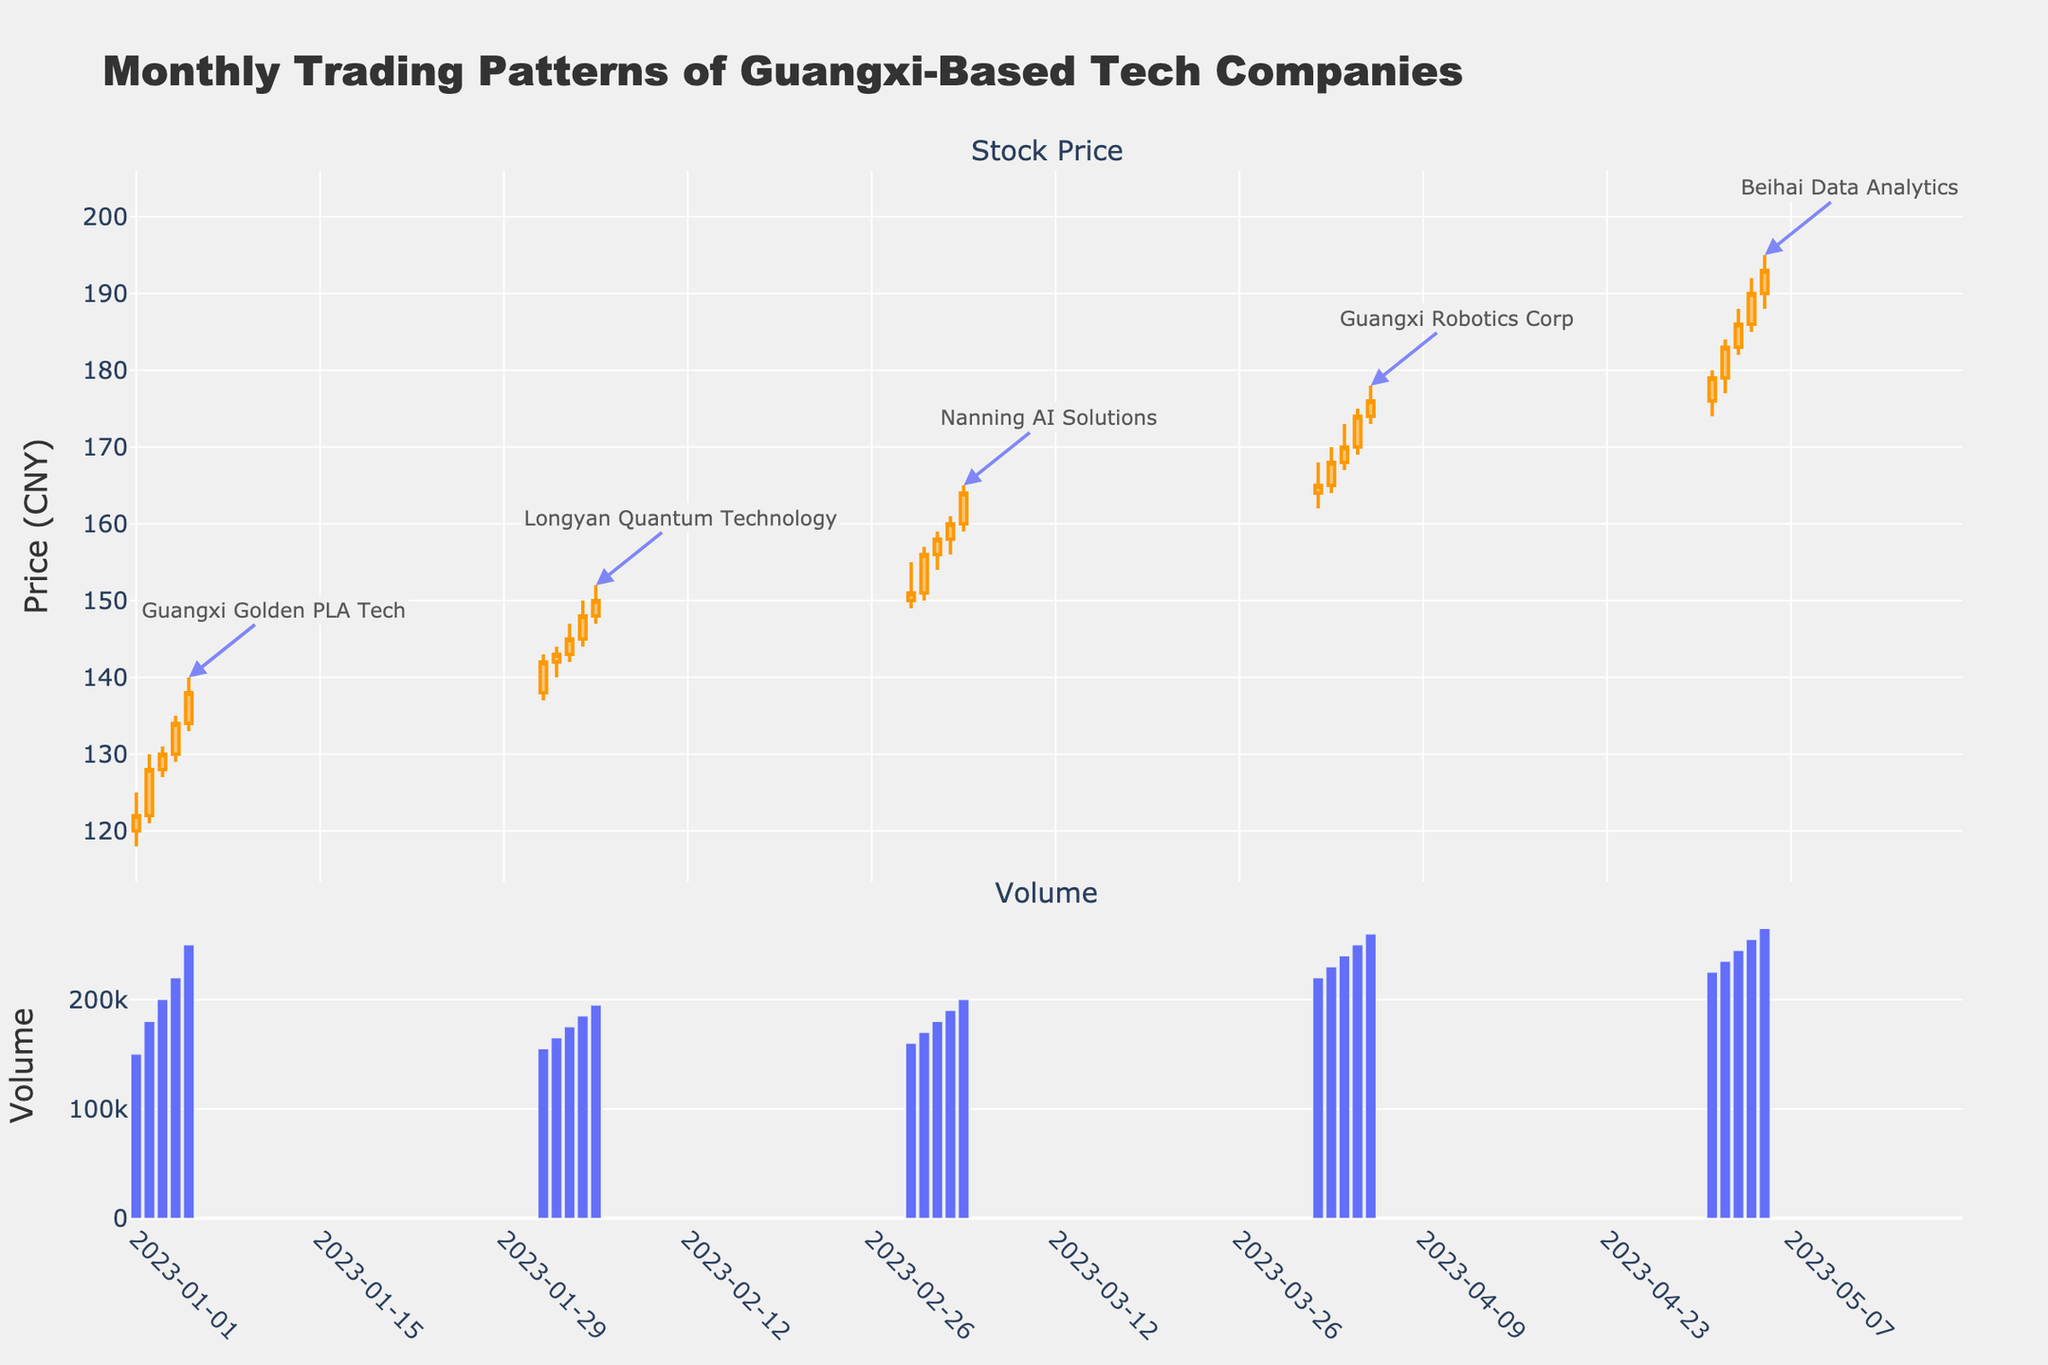What is the title of the plot? The title is positioned at the top of the figure and it provides an overview of the content being displayed.
Answer: Monthly Trading Patterns of Guangxi-Based Tech Companies What is the color used for increasing candlestick lines? The increasing candlestick lines are shown in orange color.
Answer: Orange Which company has the highest trading volume on the chart? Looking at the bar chart for volume, the highest trading volume can be found for Beihai Data Analytics on May 5th.
Answer: Beihai Data Analytics Compare the closing stock prices of Guangxi Golden PLA Tech and Longyan Quantum Technology. Which one ended higher in their respective trading months? Guangxi Golden PLA Tech’s closing price on January 5th was 138, while Longyan Quantum Technology’s closing price on February 5th was 150. Since 150 > 138, Longyan Quantum Technology ended higher.
Answer: Longyan Quantum Technology How does the volume compare between the first and last data points? The first data point on January 1 shows a volume of 150,000, and the last data point on May 5 shows a volume of 265,000. The last data point has a higher volume by (265,000 - 150,000) = 115,000.
Answer: Last data point has 115,000 more Which date saw the highest closing price for Nanning AI Solutions? Nanning AI Solutions' highest closing price is on March 5th with a closing price of 164. This can be determined by looking at the closing prices of that company's data points.
Answer: March 5 Identify the date with the lowest trading volume for Longyan Quantum Technology and provide the volume. For Longyan Quantum Technology, the lowest volume can be seen on February 1st, where it is 155,000.
Answer: February 1, 155,000 How much did the closing price increase for Guangxi Robotics Corp from April 1 to April 5? The closing price on April 1 was 165, and on April 5 it was 176. The increase is (176 - 165) = 11.
Answer: Increased by 11 Which company's stock shows the highest 'High' value shown on the chart, and what is that value? Examining the highest value for each company, Beihai Data Analytics shows the highest 'High' value at 195 on May 5.
Answer: Beihai Data Analytics, 195 